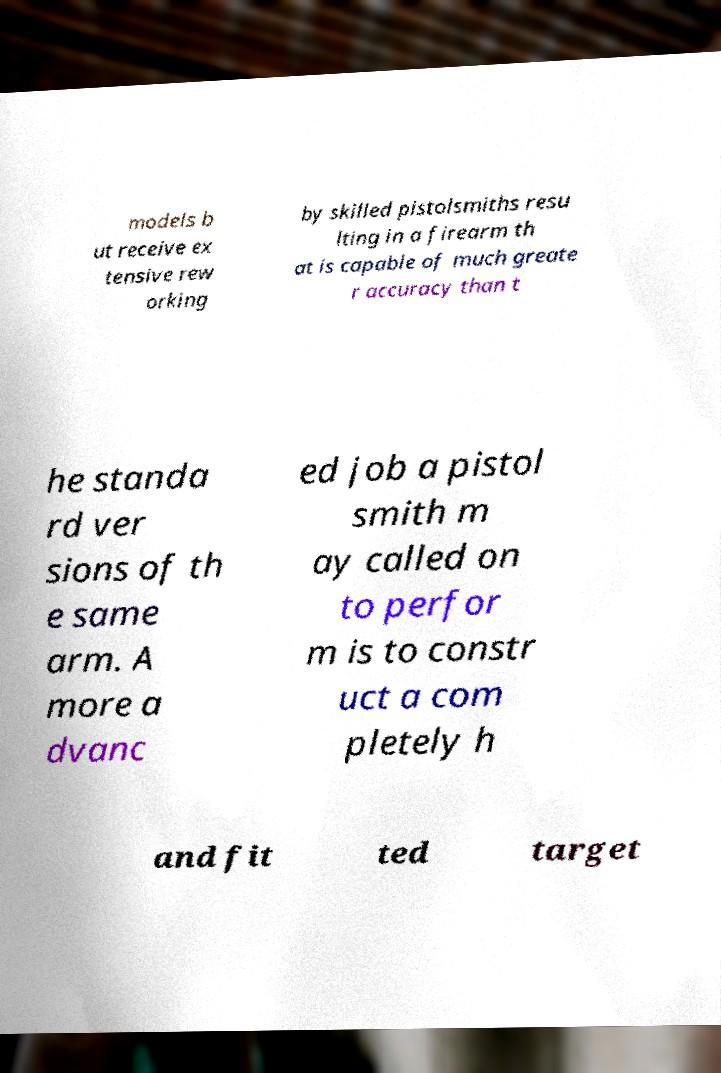Could you extract and type out the text from this image? models b ut receive ex tensive rew orking by skilled pistolsmiths resu lting in a firearm th at is capable of much greate r accuracy than t he standa rd ver sions of th e same arm. A more a dvanc ed job a pistol smith m ay called on to perfor m is to constr uct a com pletely h and fit ted target 